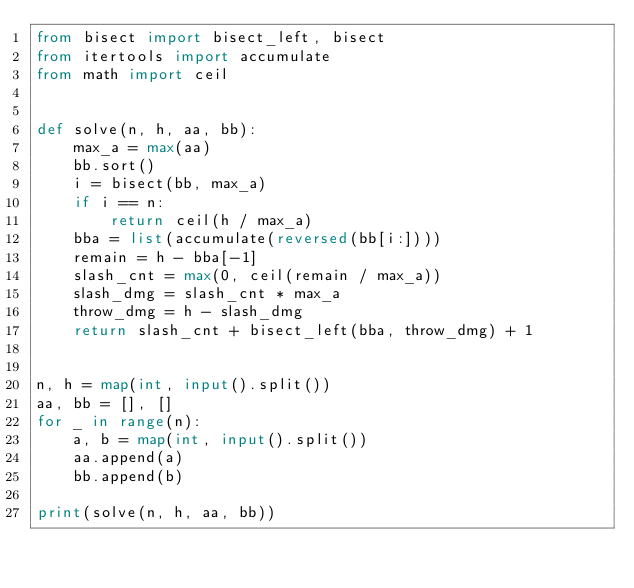<code> <loc_0><loc_0><loc_500><loc_500><_Python_>from bisect import bisect_left, bisect
from itertools import accumulate
from math import ceil


def solve(n, h, aa, bb):
    max_a = max(aa)
    bb.sort()
    i = bisect(bb, max_a)
    if i == n:
        return ceil(h / max_a)
    bba = list(accumulate(reversed(bb[i:])))
    remain = h - bba[-1]
    slash_cnt = max(0, ceil(remain / max_a))
    slash_dmg = slash_cnt * max_a
    throw_dmg = h - slash_dmg
    return slash_cnt + bisect_left(bba, throw_dmg) + 1


n, h = map(int, input().split())
aa, bb = [], []
for _ in range(n):
    a, b = map(int, input().split())
    aa.append(a)
    bb.append(b)

print(solve(n, h, aa, bb))
</code> 